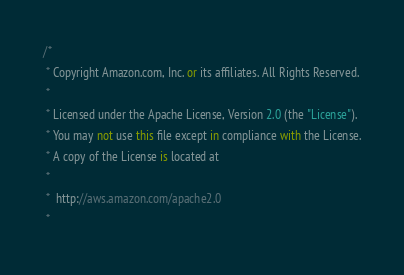Convert code to text. <code><loc_0><loc_0><loc_500><loc_500><_C#_>/*
 * Copyright Amazon.com, Inc. or its affiliates. All Rights Reserved.
 * 
 * Licensed under the Apache License, Version 2.0 (the "License").
 * You may not use this file except in compliance with the License.
 * A copy of the License is located at
 * 
 *  http://aws.amazon.com/apache2.0
 * </code> 